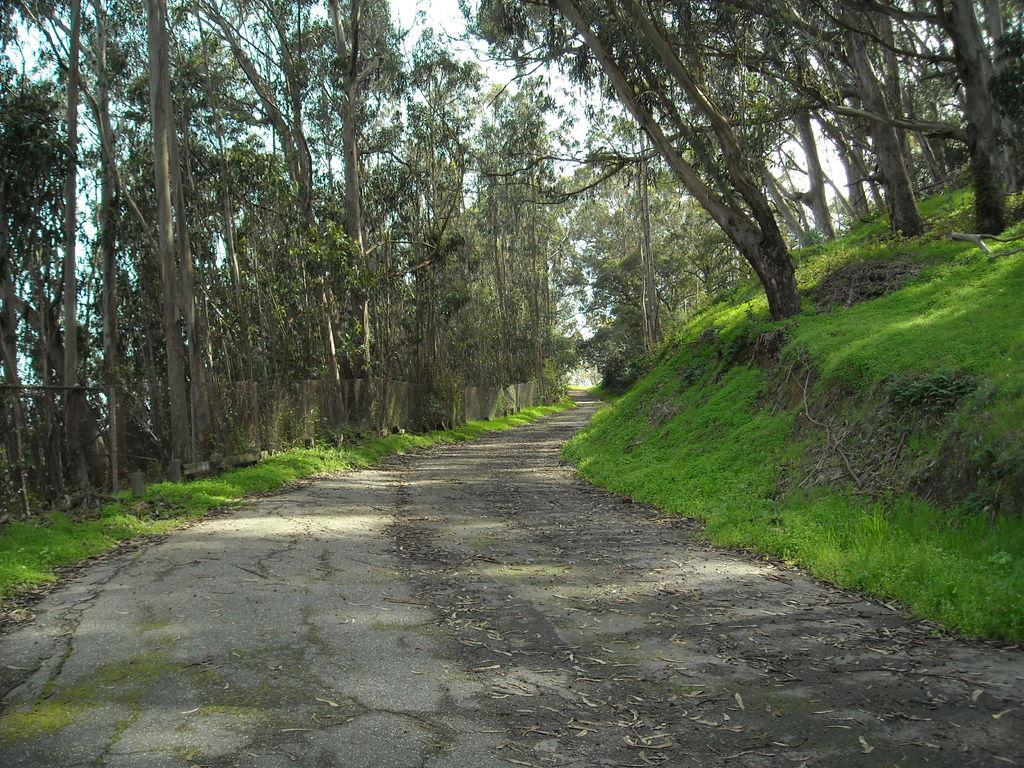What type of vegetation can be seen in the image? There are trees in the image. What else can be seen growing in the image? There is grass in the image. What part of the natural environment is visible in the image? The sky is visible in the image. What color is the jelly on the sofa in the image? There is no jelly or sofa present in the image. What is the tendency of the trees to lean towards the grass in the image? The trees do not lean towards the grass in the image; they are standing upright. 